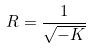<formula> <loc_0><loc_0><loc_500><loc_500>R = \frac { 1 } { \sqrt { - K } }</formula> 